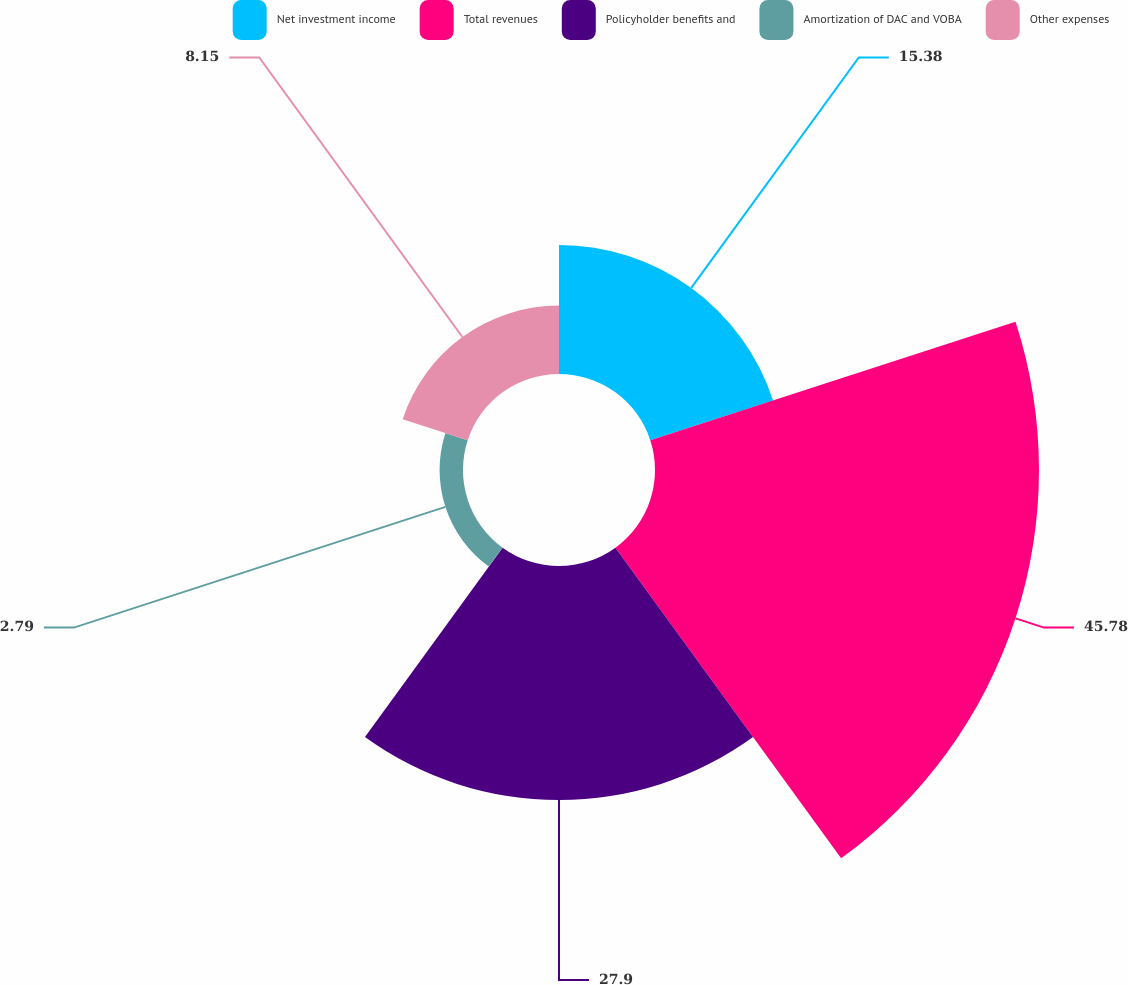Convert chart. <chart><loc_0><loc_0><loc_500><loc_500><pie_chart><fcel>Net investment income<fcel>Total revenues<fcel>Policyholder benefits and<fcel>Amortization of DAC and VOBA<fcel>Other expenses<nl><fcel>15.38%<fcel>45.77%<fcel>27.9%<fcel>2.79%<fcel>8.15%<nl></chart> 